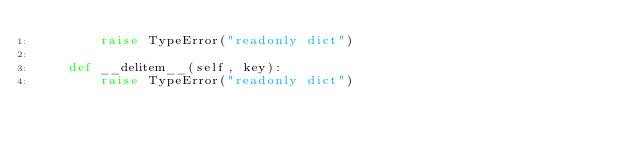Convert code to text. <code><loc_0><loc_0><loc_500><loc_500><_Python_>        raise TypeError("readonly dict")

    def __delitem__(self, key):
        raise TypeError("readonly dict")
</code> 